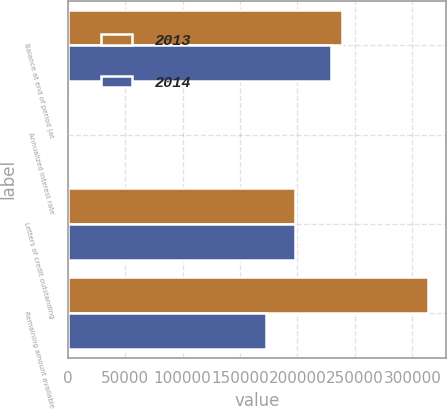Convert chart to OTSL. <chart><loc_0><loc_0><loc_500><loc_500><stacked_bar_chart><ecel><fcel>Balance at end of period (at<fcel>Annualized interest rate<fcel>Letters of credit outstanding<fcel>Remaining amount available<nl><fcel>2013<fcel>238450<fcel>0.32<fcel>198000<fcel>313550<nl><fcel>2014<fcel>229140<fcel>0.3<fcel>198000<fcel>172860<nl></chart> 